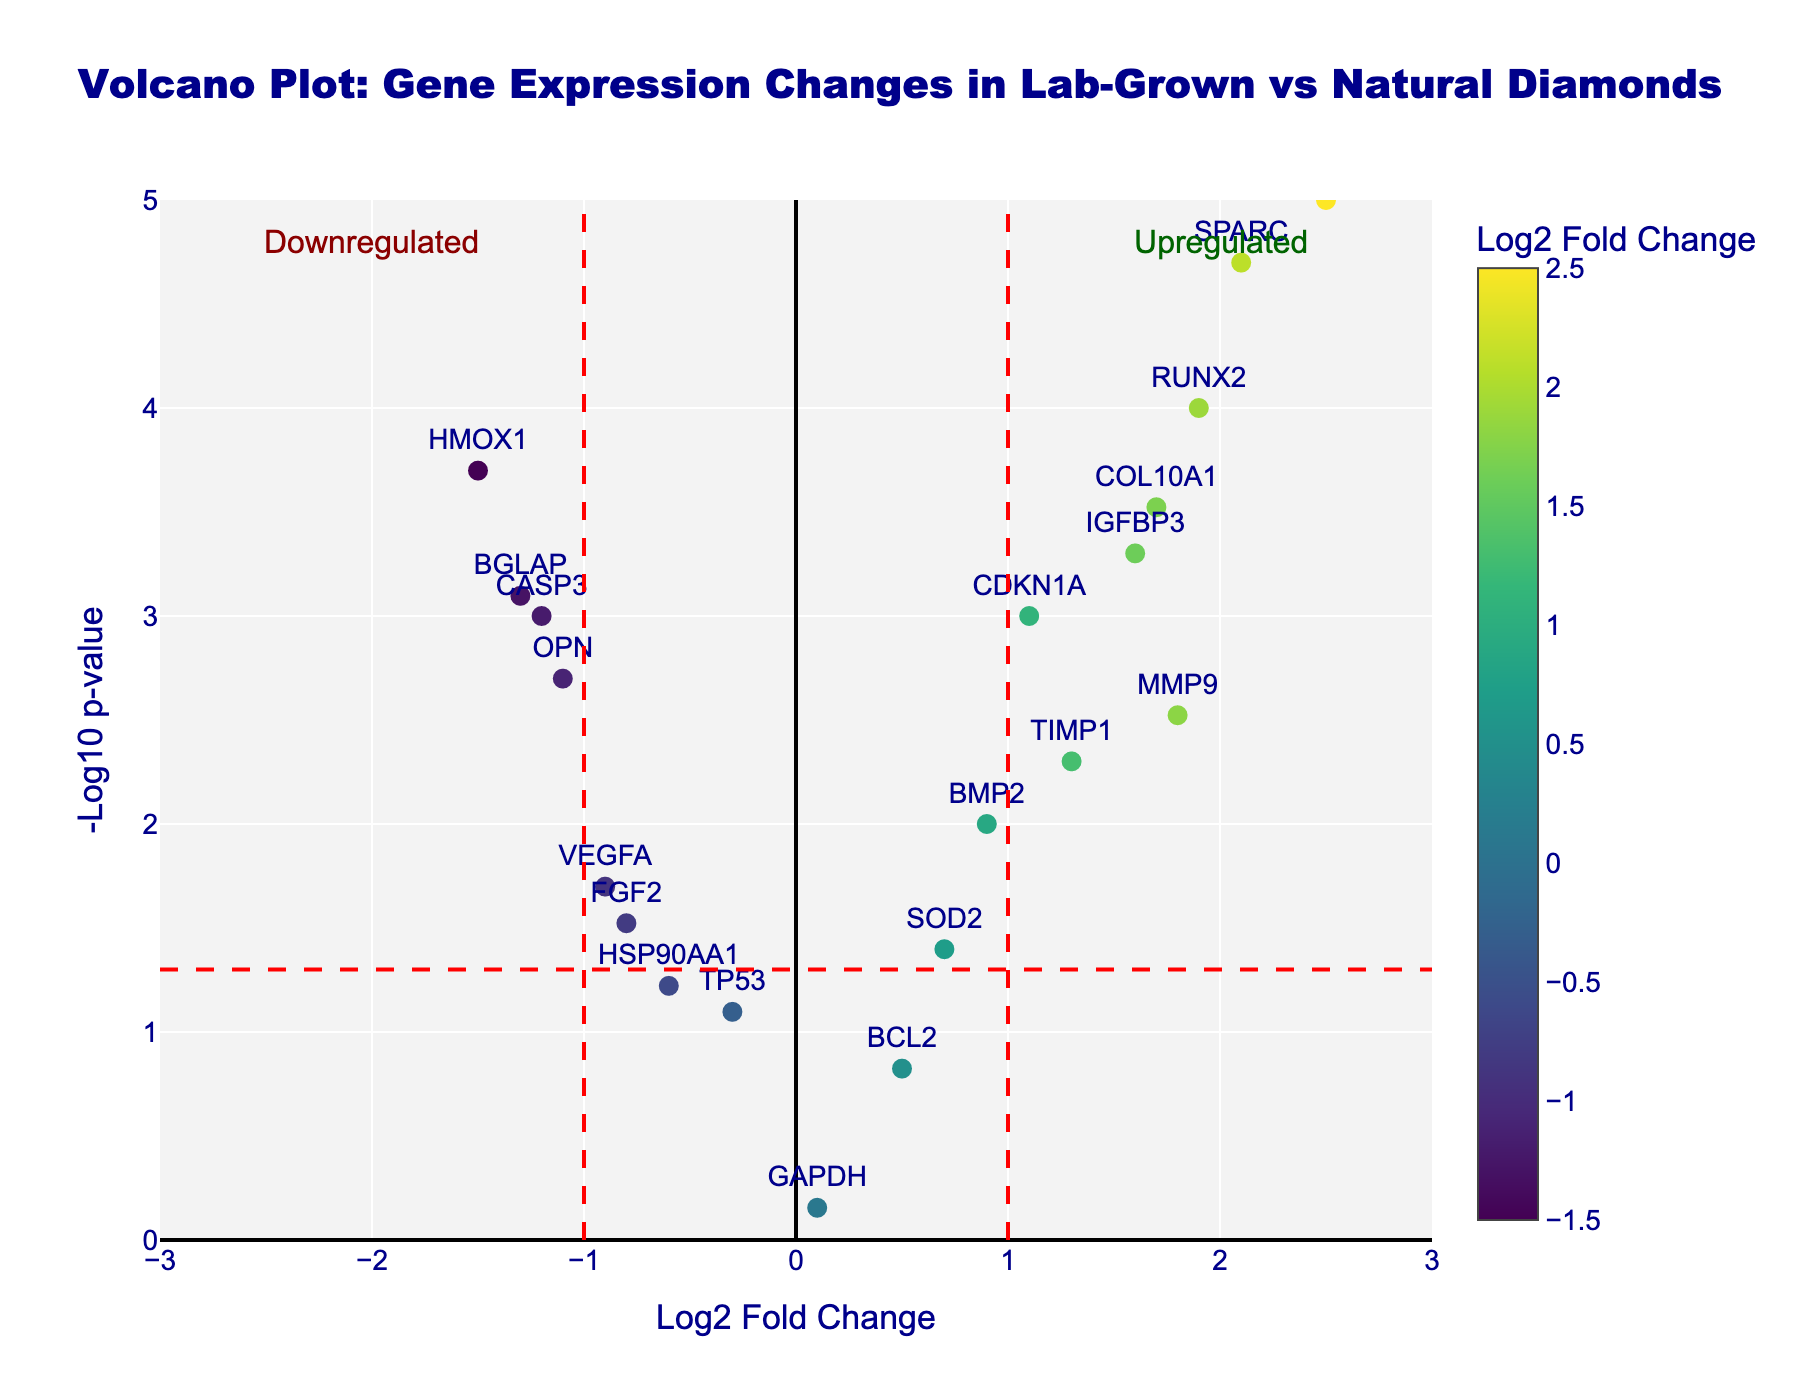What's the title of the plot? The title of the plot is displayed at the top center of the figure in bold and large font.
Answer: Volcano Plot: Gene Expression Changes in Lab-Grown vs Natural Diamonds What does the x-axis represent? The x-axis title is labeled "Log2 Fold Change". It shows changes in gene expression levels between the lab-grown and natural diamonds, where positive values indicate upregulation, and negative values indicate downregulation.
Answer: Log2 Fold Change How many genes have a -log10 p-value greater than 3? To determine this, look at data points with a -log10 p-value above 3 on the y-axis. According to the plot, there are several points above this threshold.
Answer: 6 What is the -log10 p-value threshold indicated by a horizontal red dashed line? The horizontal red dashed line shows the p-value cut-off significance, which typically corresponds to p = 0.05. -log10(0.05) ≈ 1.3.
Answer: 1.3 Which gene has the highest -log10 p-value? Inspect the highest point on the y-axis and refer to the label of that data point. The gene at the highest -log10 p-value is most likely SPARC.
Answer: SPARC Which genes are significantly upregulated (log2 fold change > 1 and p-value < 0.05)? To answer this, look for data points to the right of log2 fold change > 1 and above the horizontal significance line. Genes here include COL1A1, SPARC, IGFBP3, and RUNX2.
Answer: COL1A1, SPARC, IGFBP3, RUNX2 Which genes are significantly downregulated (log2 fold change < -1 and p-value < 0.05)? To find this, look at data points to the left of log2 fold change < -1 and above the horizontal significance line. These genes include CASP3, HMOX1, OPN, and BGLAP.
Answer: CASP3, HMOX1, OPN, BGLAP What is the log2 fold change for the gene MMP9? Look for the data point labeled MMP9. The log2 fold change value for this gene is shown on the x-axis.
Answer: 1.8 Compare the log2 fold changes of COL1A1 and TP53. Which one is higher? Check the x-axis positions of COL1A1 and TP53. COL1A1's log2 fold change is higher as it is located farther to the right compared to TP53.
Answer: COL1A1 